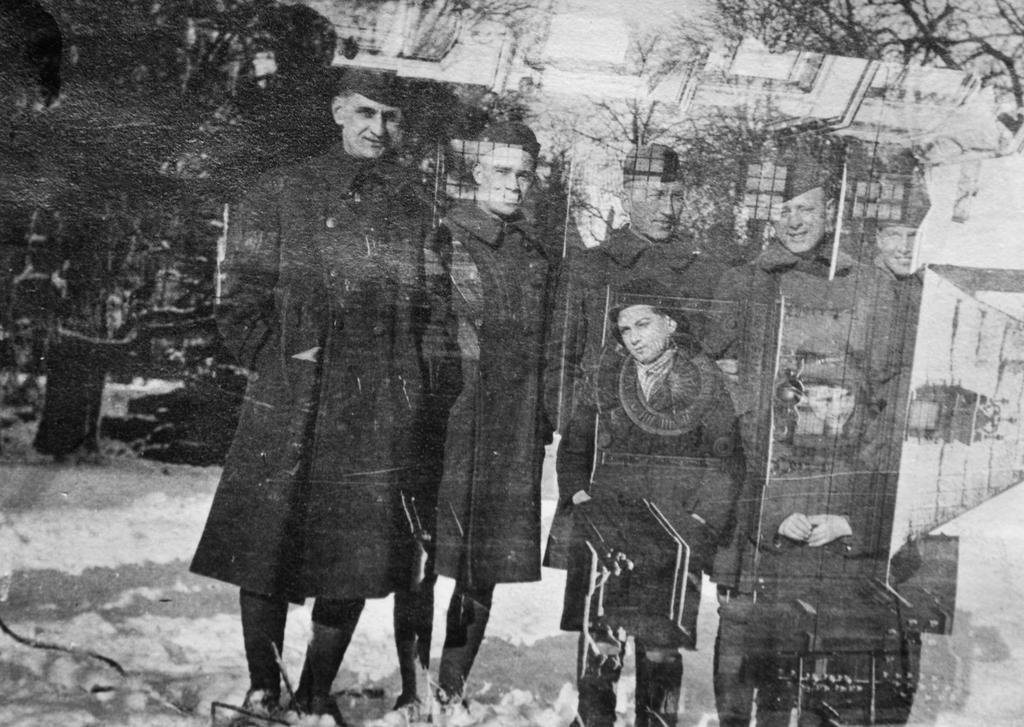In one or two sentences, can you explain what this image depicts? In this picture there is a reflection of a group of people on the mirror and trees and buildings and at the bottom there is snow and at the top there is sky. 